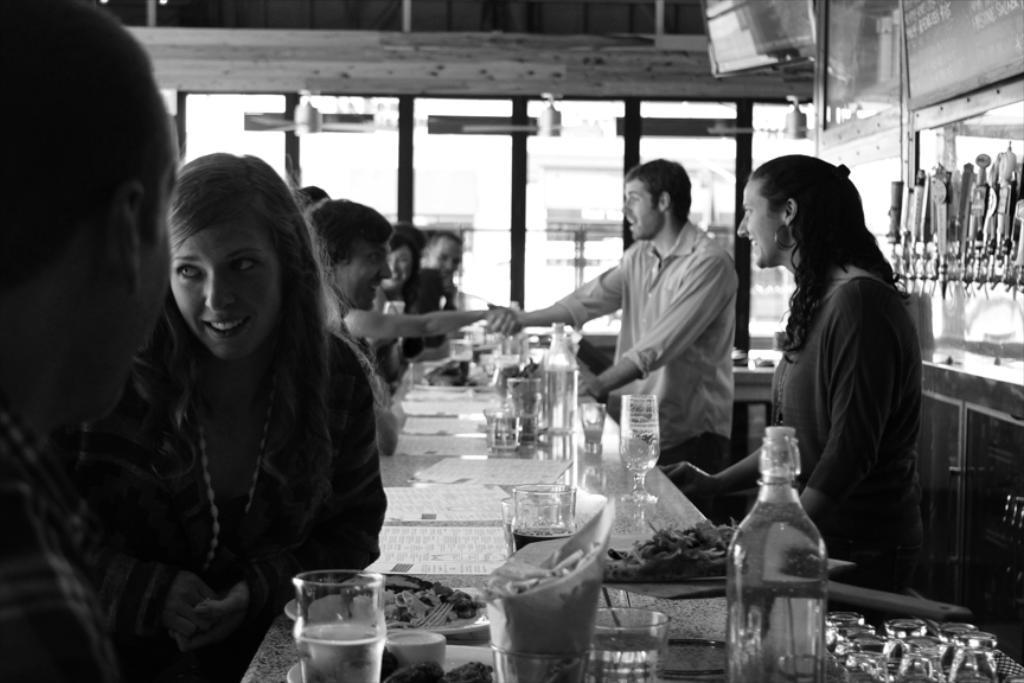Who is on the left side of the image? There is a woman on the left side of the image. How many people are on the right side of the image? There are two persons on the right side of the image. What is present in the image besides the people? There is a table in the image, and it has glass bottles and food on it. What type of establishment might the image be depicting? The setting appears to be in a restaurant. What type of destruction can be seen in the image? There is no destruction present in the image; it depicts a woman and two persons in a restaurant setting. What is the view like from the table in the image? The facts provided do not give information about the view from the table, as the focus is on the people and objects in the image. 